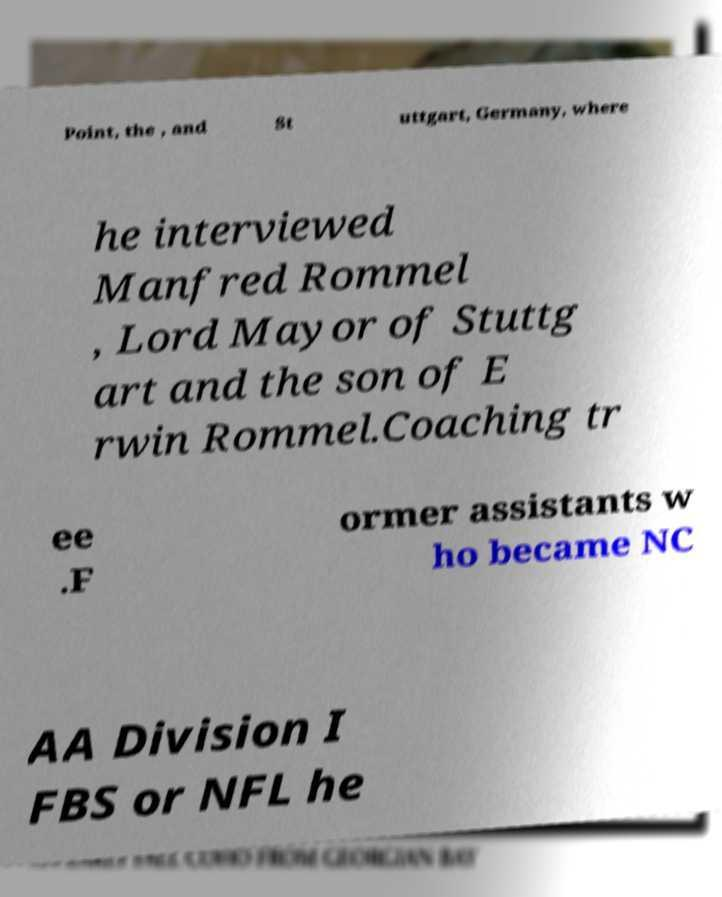Please read and relay the text visible in this image. What does it say? Point, the , and St uttgart, Germany, where he interviewed Manfred Rommel , Lord Mayor of Stuttg art and the son of E rwin Rommel.Coaching tr ee .F ormer assistants w ho became NC AA Division I FBS or NFL he 